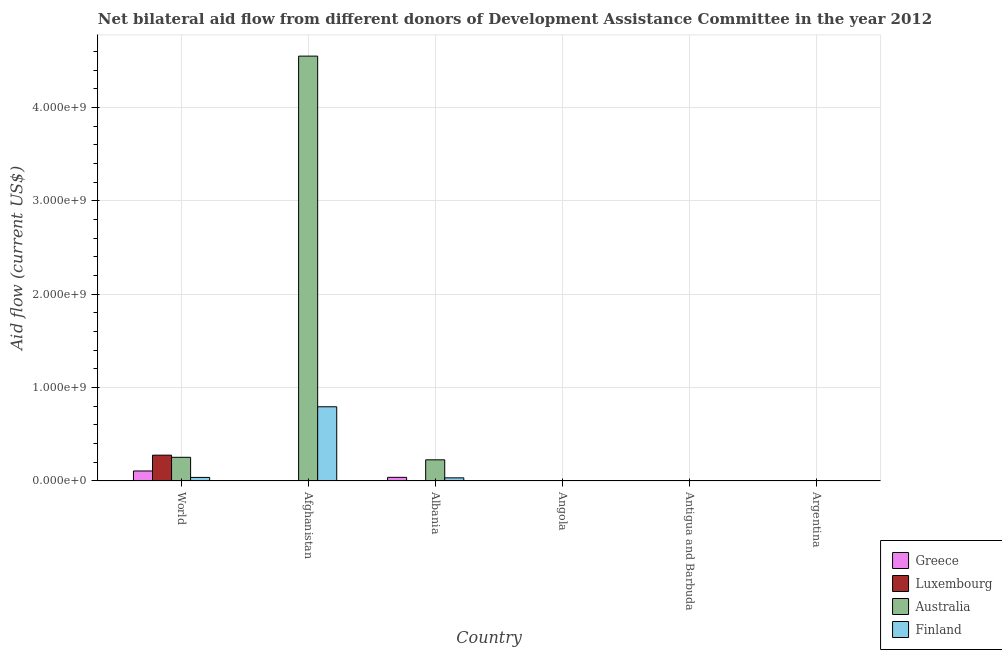How many groups of bars are there?
Give a very brief answer. 6. Are the number of bars per tick equal to the number of legend labels?
Your answer should be very brief. Yes. Are the number of bars on each tick of the X-axis equal?
Your answer should be compact. Yes. How many bars are there on the 5th tick from the right?
Offer a very short reply. 4. What is the label of the 4th group of bars from the left?
Your response must be concise. Angola. What is the amount of aid given by greece in Angola?
Ensure brevity in your answer.  2.00e+04. Across all countries, what is the maximum amount of aid given by greece?
Provide a short and direct response. 1.07e+08. Across all countries, what is the minimum amount of aid given by greece?
Your answer should be very brief. 2.00e+04. In which country was the amount of aid given by luxembourg maximum?
Your response must be concise. World. In which country was the amount of aid given by greece minimum?
Make the answer very short. Angola. What is the total amount of aid given by australia in the graph?
Keep it short and to the point. 5.03e+09. What is the difference between the amount of aid given by greece in Albania and that in World?
Give a very brief answer. -6.80e+07. What is the difference between the amount of aid given by australia in Afghanistan and the amount of aid given by greece in Angola?
Offer a terse response. 4.55e+09. What is the average amount of aid given by luxembourg per country?
Offer a very short reply. 4.67e+07. What is the difference between the amount of aid given by luxembourg and amount of aid given by australia in Angola?
Your response must be concise. 3.00e+04. What is the ratio of the amount of aid given by finland in Albania to that in Angola?
Your answer should be compact. 210.75. Is the difference between the amount of aid given by australia in Argentina and World greater than the difference between the amount of aid given by greece in Argentina and World?
Your response must be concise. No. What is the difference between the highest and the second highest amount of aid given by luxembourg?
Your response must be concise. 2.74e+08. What is the difference between the highest and the lowest amount of aid given by greece?
Your answer should be very brief. 1.07e+08. What does the 2nd bar from the right in Afghanistan represents?
Your answer should be compact. Australia. Is it the case that in every country, the sum of the amount of aid given by greece and amount of aid given by luxembourg is greater than the amount of aid given by australia?
Provide a short and direct response. No. How many countries are there in the graph?
Provide a short and direct response. 6. What is the difference between two consecutive major ticks on the Y-axis?
Keep it short and to the point. 1.00e+09. Does the graph contain grids?
Ensure brevity in your answer.  Yes. Where does the legend appear in the graph?
Give a very brief answer. Bottom right. What is the title of the graph?
Your answer should be very brief. Net bilateral aid flow from different donors of Development Assistance Committee in the year 2012. What is the label or title of the X-axis?
Make the answer very short. Country. What is the Aid flow (current US$) in Greece in World?
Provide a short and direct response. 1.07e+08. What is the Aid flow (current US$) in Luxembourg in World?
Provide a succinct answer. 2.77e+08. What is the Aid flow (current US$) of Australia in World?
Provide a short and direct response. 2.54e+08. What is the Aid flow (current US$) in Finland in World?
Your answer should be very brief. 3.82e+07. What is the Aid flow (current US$) in Greece in Afghanistan?
Offer a terse response. 7.70e+05. What is the Aid flow (current US$) of Luxembourg in Afghanistan?
Your response must be concise. 3.02e+06. What is the Aid flow (current US$) in Australia in Afghanistan?
Offer a very short reply. 4.55e+09. What is the Aid flow (current US$) in Finland in Afghanistan?
Give a very brief answer. 7.95e+08. What is the Aid flow (current US$) in Greece in Albania?
Your answer should be compact. 3.92e+07. What is the Aid flow (current US$) in Australia in Albania?
Your response must be concise. 2.27e+08. What is the Aid flow (current US$) in Finland in Albania?
Provide a succinct answer. 3.37e+07. What is the Aid flow (current US$) of Greece in Antigua and Barbuda?
Your answer should be very brief. 5.00e+04. What is the Aid flow (current US$) of Luxembourg in Antigua and Barbuda?
Make the answer very short. 1.20e+05. What is the Aid flow (current US$) of Australia in Antigua and Barbuda?
Your response must be concise. 1.90e+05. What is the Aid flow (current US$) of Finland in Antigua and Barbuda?
Make the answer very short. 1.86e+06. What is the Aid flow (current US$) of Greece in Argentina?
Offer a terse response. 3.40e+05. What is the Aid flow (current US$) of Luxembourg in Argentina?
Provide a succinct answer. 1.00e+05. What is the Aid flow (current US$) in Finland in Argentina?
Provide a short and direct response. 2.00e+04. Across all countries, what is the maximum Aid flow (current US$) in Greece?
Keep it short and to the point. 1.07e+08. Across all countries, what is the maximum Aid flow (current US$) in Luxembourg?
Give a very brief answer. 2.77e+08. Across all countries, what is the maximum Aid flow (current US$) of Australia?
Ensure brevity in your answer.  4.55e+09. Across all countries, what is the maximum Aid flow (current US$) of Finland?
Keep it short and to the point. 7.95e+08. Across all countries, what is the minimum Aid flow (current US$) in Luxembourg?
Provide a short and direct response. 9.00e+04. Across all countries, what is the minimum Aid flow (current US$) in Australia?
Your response must be concise. 6.00e+04. What is the total Aid flow (current US$) of Greece in the graph?
Your answer should be compact. 1.48e+08. What is the total Aid flow (current US$) of Luxembourg in the graph?
Ensure brevity in your answer.  2.80e+08. What is the total Aid flow (current US$) of Australia in the graph?
Provide a short and direct response. 5.03e+09. What is the total Aid flow (current US$) in Finland in the graph?
Keep it short and to the point. 8.69e+08. What is the difference between the Aid flow (current US$) in Greece in World and that in Afghanistan?
Your response must be concise. 1.07e+08. What is the difference between the Aid flow (current US$) of Luxembourg in World and that in Afghanistan?
Your response must be concise. 2.74e+08. What is the difference between the Aid flow (current US$) in Australia in World and that in Afghanistan?
Keep it short and to the point. -4.30e+09. What is the difference between the Aid flow (current US$) of Finland in World and that in Afghanistan?
Offer a terse response. -7.57e+08. What is the difference between the Aid flow (current US$) in Greece in World and that in Albania?
Offer a terse response. 6.80e+07. What is the difference between the Aid flow (current US$) in Luxembourg in World and that in Albania?
Provide a short and direct response. 2.77e+08. What is the difference between the Aid flow (current US$) of Australia in World and that in Albania?
Your answer should be very brief. 2.71e+07. What is the difference between the Aid flow (current US$) of Finland in World and that in Albania?
Your answer should be compact. 4.53e+06. What is the difference between the Aid flow (current US$) of Greece in World and that in Angola?
Offer a terse response. 1.07e+08. What is the difference between the Aid flow (current US$) in Luxembourg in World and that in Angola?
Your answer should be compact. 2.77e+08. What is the difference between the Aid flow (current US$) of Australia in World and that in Angola?
Offer a very short reply. 2.54e+08. What is the difference between the Aid flow (current US$) in Finland in World and that in Angola?
Provide a short and direct response. 3.81e+07. What is the difference between the Aid flow (current US$) in Greece in World and that in Antigua and Barbuda?
Provide a succinct answer. 1.07e+08. What is the difference between the Aid flow (current US$) of Luxembourg in World and that in Antigua and Barbuda?
Keep it short and to the point. 2.77e+08. What is the difference between the Aid flow (current US$) of Australia in World and that in Antigua and Barbuda?
Give a very brief answer. 2.54e+08. What is the difference between the Aid flow (current US$) of Finland in World and that in Antigua and Barbuda?
Give a very brief answer. 3.64e+07. What is the difference between the Aid flow (current US$) in Greece in World and that in Argentina?
Give a very brief answer. 1.07e+08. What is the difference between the Aid flow (current US$) in Luxembourg in World and that in Argentina?
Offer a terse response. 2.77e+08. What is the difference between the Aid flow (current US$) in Australia in World and that in Argentina?
Your response must be concise. 2.54e+08. What is the difference between the Aid flow (current US$) in Finland in World and that in Argentina?
Make the answer very short. 3.82e+07. What is the difference between the Aid flow (current US$) of Greece in Afghanistan and that in Albania?
Your answer should be compact. -3.85e+07. What is the difference between the Aid flow (current US$) in Luxembourg in Afghanistan and that in Albania?
Give a very brief answer. 2.86e+06. What is the difference between the Aid flow (current US$) of Australia in Afghanistan and that in Albania?
Provide a short and direct response. 4.32e+09. What is the difference between the Aid flow (current US$) in Finland in Afghanistan and that in Albania?
Offer a very short reply. 7.61e+08. What is the difference between the Aid flow (current US$) in Greece in Afghanistan and that in Angola?
Ensure brevity in your answer.  7.50e+05. What is the difference between the Aid flow (current US$) of Luxembourg in Afghanistan and that in Angola?
Ensure brevity in your answer.  2.93e+06. What is the difference between the Aid flow (current US$) in Australia in Afghanistan and that in Angola?
Keep it short and to the point. 4.55e+09. What is the difference between the Aid flow (current US$) of Finland in Afghanistan and that in Angola?
Your answer should be compact. 7.95e+08. What is the difference between the Aid flow (current US$) in Greece in Afghanistan and that in Antigua and Barbuda?
Provide a succinct answer. 7.20e+05. What is the difference between the Aid flow (current US$) of Luxembourg in Afghanistan and that in Antigua and Barbuda?
Your answer should be compact. 2.90e+06. What is the difference between the Aid flow (current US$) in Australia in Afghanistan and that in Antigua and Barbuda?
Your answer should be very brief. 4.55e+09. What is the difference between the Aid flow (current US$) of Finland in Afghanistan and that in Antigua and Barbuda?
Give a very brief answer. 7.93e+08. What is the difference between the Aid flow (current US$) in Greece in Afghanistan and that in Argentina?
Make the answer very short. 4.30e+05. What is the difference between the Aid flow (current US$) in Luxembourg in Afghanistan and that in Argentina?
Offer a terse response. 2.92e+06. What is the difference between the Aid flow (current US$) in Australia in Afghanistan and that in Argentina?
Keep it short and to the point. 4.55e+09. What is the difference between the Aid flow (current US$) in Finland in Afghanistan and that in Argentina?
Keep it short and to the point. 7.95e+08. What is the difference between the Aid flow (current US$) in Greece in Albania and that in Angola?
Your response must be concise. 3.92e+07. What is the difference between the Aid flow (current US$) of Luxembourg in Albania and that in Angola?
Offer a very short reply. 7.00e+04. What is the difference between the Aid flow (current US$) in Australia in Albania and that in Angola?
Offer a terse response. 2.27e+08. What is the difference between the Aid flow (current US$) in Finland in Albania and that in Angola?
Your response must be concise. 3.36e+07. What is the difference between the Aid flow (current US$) in Greece in Albania and that in Antigua and Barbuda?
Give a very brief answer. 3.92e+07. What is the difference between the Aid flow (current US$) in Luxembourg in Albania and that in Antigua and Barbuda?
Offer a terse response. 4.00e+04. What is the difference between the Aid flow (current US$) of Australia in Albania and that in Antigua and Barbuda?
Provide a short and direct response. 2.26e+08. What is the difference between the Aid flow (current US$) in Finland in Albania and that in Antigua and Barbuda?
Keep it short and to the point. 3.19e+07. What is the difference between the Aid flow (current US$) of Greece in Albania and that in Argentina?
Provide a succinct answer. 3.89e+07. What is the difference between the Aid flow (current US$) in Australia in Albania and that in Argentina?
Provide a short and direct response. 2.27e+08. What is the difference between the Aid flow (current US$) in Finland in Albania and that in Argentina?
Ensure brevity in your answer.  3.37e+07. What is the difference between the Aid flow (current US$) in Luxembourg in Angola and that in Antigua and Barbuda?
Provide a short and direct response. -3.00e+04. What is the difference between the Aid flow (current US$) of Finland in Angola and that in Antigua and Barbuda?
Your answer should be very brief. -1.70e+06. What is the difference between the Aid flow (current US$) in Greece in Angola and that in Argentina?
Offer a terse response. -3.20e+05. What is the difference between the Aid flow (current US$) of Luxembourg in Angola and that in Argentina?
Keep it short and to the point. -10000. What is the difference between the Aid flow (current US$) in Australia in Angola and that in Argentina?
Your response must be concise. -8.00e+04. What is the difference between the Aid flow (current US$) in Greece in Antigua and Barbuda and that in Argentina?
Ensure brevity in your answer.  -2.90e+05. What is the difference between the Aid flow (current US$) of Australia in Antigua and Barbuda and that in Argentina?
Your answer should be compact. 5.00e+04. What is the difference between the Aid flow (current US$) in Finland in Antigua and Barbuda and that in Argentina?
Offer a terse response. 1.84e+06. What is the difference between the Aid flow (current US$) in Greece in World and the Aid flow (current US$) in Luxembourg in Afghanistan?
Give a very brief answer. 1.04e+08. What is the difference between the Aid flow (current US$) in Greece in World and the Aid flow (current US$) in Australia in Afghanistan?
Provide a short and direct response. -4.44e+09. What is the difference between the Aid flow (current US$) of Greece in World and the Aid flow (current US$) of Finland in Afghanistan?
Provide a succinct answer. -6.88e+08. What is the difference between the Aid flow (current US$) in Luxembourg in World and the Aid flow (current US$) in Australia in Afghanistan?
Your answer should be compact. -4.27e+09. What is the difference between the Aid flow (current US$) in Luxembourg in World and the Aid flow (current US$) in Finland in Afghanistan?
Your answer should be compact. -5.18e+08. What is the difference between the Aid flow (current US$) of Australia in World and the Aid flow (current US$) of Finland in Afghanistan?
Make the answer very short. -5.41e+08. What is the difference between the Aid flow (current US$) in Greece in World and the Aid flow (current US$) in Luxembourg in Albania?
Offer a very short reply. 1.07e+08. What is the difference between the Aid flow (current US$) in Greece in World and the Aid flow (current US$) in Australia in Albania?
Ensure brevity in your answer.  -1.19e+08. What is the difference between the Aid flow (current US$) of Greece in World and the Aid flow (current US$) of Finland in Albania?
Your answer should be very brief. 7.36e+07. What is the difference between the Aid flow (current US$) in Luxembourg in World and the Aid flow (current US$) in Australia in Albania?
Give a very brief answer. 5.00e+07. What is the difference between the Aid flow (current US$) of Luxembourg in World and the Aid flow (current US$) of Finland in Albania?
Ensure brevity in your answer.  2.43e+08. What is the difference between the Aid flow (current US$) of Australia in World and the Aid flow (current US$) of Finland in Albania?
Keep it short and to the point. 2.20e+08. What is the difference between the Aid flow (current US$) of Greece in World and the Aid flow (current US$) of Luxembourg in Angola?
Provide a succinct answer. 1.07e+08. What is the difference between the Aid flow (current US$) in Greece in World and the Aid flow (current US$) in Australia in Angola?
Make the answer very short. 1.07e+08. What is the difference between the Aid flow (current US$) of Greece in World and the Aid flow (current US$) of Finland in Angola?
Ensure brevity in your answer.  1.07e+08. What is the difference between the Aid flow (current US$) in Luxembourg in World and the Aid flow (current US$) in Australia in Angola?
Ensure brevity in your answer.  2.77e+08. What is the difference between the Aid flow (current US$) of Luxembourg in World and the Aid flow (current US$) of Finland in Angola?
Keep it short and to the point. 2.77e+08. What is the difference between the Aid flow (current US$) in Australia in World and the Aid flow (current US$) in Finland in Angola?
Make the answer very short. 2.54e+08. What is the difference between the Aid flow (current US$) in Greece in World and the Aid flow (current US$) in Luxembourg in Antigua and Barbuda?
Provide a succinct answer. 1.07e+08. What is the difference between the Aid flow (current US$) of Greece in World and the Aid flow (current US$) of Australia in Antigua and Barbuda?
Make the answer very short. 1.07e+08. What is the difference between the Aid flow (current US$) of Greece in World and the Aid flow (current US$) of Finland in Antigua and Barbuda?
Ensure brevity in your answer.  1.05e+08. What is the difference between the Aid flow (current US$) of Luxembourg in World and the Aid flow (current US$) of Australia in Antigua and Barbuda?
Offer a very short reply. 2.76e+08. What is the difference between the Aid flow (current US$) in Luxembourg in World and the Aid flow (current US$) in Finland in Antigua and Barbuda?
Offer a terse response. 2.75e+08. What is the difference between the Aid flow (current US$) of Australia in World and the Aid flow (current US$) of Finland in Antigua and Barbuda?
Make the answer very short. 2.52e+08. What is the difference between the Aid flow (current US$) of Greece in World and the Aid flow (current US$) of Luxembourg in Argentina?
Make the answer very short. 1.07e+08. What is the difference between the Aid flow (current US$) in Greece in World and the Aid flow (current US$) in Australia in Argentina?
Offer a very short reply. 1.07e+08. What is the difference between the Aid flow (current US$) in Greece in World and the Aid flow (current US$) in Finland in Argentina?
Ensure brevity in your answer.  1.07e+08. What is the difference between the Aid flow (current US$) of Luxembourg in World and the Aid flow (current US$) of Australia in Argentina?
Provide a short and direct response. 2.77e+08. What is the difference between the Aid flow (current US$) in Luxembourg in World and the Aid flow (current US$) in Finland in Argentina?
Your answer should be very brief. 2.77e+08. What is the difference between the Aid flow (current US$) in Australia in World and the Aid flow (current US$) in Finland in Argentina?
Your response must be concise. 2.54e+08. What is the difference between the Aid flow (current US$) in Greece in Afghanistan and the Aid flow (current US$) in Australia in Albania?
Provide a short and direct response. -2.26e+08. What is the difference between the Aid flow (current US$) in Greece in Afghanistan and the Aid flow (current US$) in Finland in Albania?
Offer a very short reply. -3.30e+07. What is the difference between the Aid flow (current US$) of Luxembourg in Afghanistan and the Aid flow (current US$) of Australia in Albania?
Your answer should be very brief. -2.24e+08. What is the difference between the Aid flow (current US$) of Luxembourg in Afghanistan and the Aid flow (current US$) of Finland in Albania?
Your answer should be very brief. -3.07e+07. What is the difference between the Aid flow (current US$) in Australia in Afghanistan and the Aid flow (current US$) in Finland in Albania?
Your response must be concise. 4.52e+09. What is the difference between the Aid flow (current US$) of Greece in Afghanistan and the Aid flow (current US$) of Luxembourg in Angola?
Provide a succinct answer. 6.80e+05. What is the difference between the Aid flow (current US$) in Greece in Afghanistan and the Aid flow (current US$) in Australia in Angola?
Keep it short and to the point. 7.10e+05. What is the difference between the Aid flow (current US$) of Greece in Afghanistan and the Aid flow (current US$) of Finland in Angola?
Your answer should be compact. 6.10e+05. What is the difference between the Aid flow (current US$) of Luxembourg in Afghanistan and the Aid flow (current US$) of Australia in Angola?
Offer a very short reply. 2.96e+06. What is the difference between the Aid flow (current US$) in Luxembourg in Afghanistan and the Aid flow (current US$) in Finland in Angola?
Offer a terse response. 2.86e+06. What is the difference between the Aid flow (current US$) of Australia in Afghanistan and the Aid flow (current US$) of Finland in Angola?
Offer a very short reply. 4.55e+09. What is the difference between the Aid flow (current US$) in Greece in Afghanistan and the Aid flow (current US$) in Luxembourg in Antigua and Barbuda?
Make the answer very short. 6.50e+05. What is the difference between the Aid flow (current US$) in Greece in Afghanistan and the Aid flow (current US$) in Australia in Antigua and Barbuda?
Provide a short and direct response. 5.80e+05. What is the difference between the Aid flow (current US$) of Greece in Afghanistan and the Aid flow (current US$) of Finland in Antigua and Barbuda?
Offer a terse response. -1.09e+06. What is the difference between the Aid flow (current US$) in Luxembourg in Afghanistan and the Aid flow (current US$) in Australia in Antigua and Barbuda?
Make the answer very short. 2.83e+06. What is the difference between the Aid flow (current US$) of Luxembourg in Afghanistan and the Aid flow (current US$) of Finland in Antigua and Barbuda?
Offer a terse response. 1.16e+06. What is the difference between the Aid flow (current US$) of Australia in Afghanistan and the Aid flow (current US$) of Finland in Antigua and Barbuda?
Your answer should be very brief. 4.55e+09. What is the difference between the Aid flow (current US$) in Greece in Afghanistan and the Aid flow (current US$) in Luxembourg in Argentina?
Offer a very short reply. 6.70e+05. What is the difference between the Aid flow (current US$) in Greece in Afghanistan and the Aid flow (current US$) in Australia in Argentina?
Ensure brevity in your answer.  6.30e+05. What is the difference between the Aid flow (current US$) in Greece in Afghanistan and the Aid flow (current US$) in Finland in Argentina?
Make the answer very short. 7.50e+05. What is the difference between the Aid flow (current US$) of Luxembourg in Afghanistan and the Aid flow (current US$) of Australia in Argentina?
Offer a very short reply. 2.88e+06. What is the difference between the Aid flow (current US$) in Australia in Afghanistan and the Aid flow (current US$) in Finland in Argentina?
Your response must be concise. 4.55e+09. What is the difference between the Aid flow (current US$) in Greece in Albania and the Aid flow (current US$) in Luxembourg in Angola?
Keep it short and to the point. 3.92e+07. What is the difference between the Aid flow (current US$) in Greece in Albania and the Aid flow (current US$) in Australia in Angola?
Keep it short and to the point. 3.92e+07. What is the difference between the Aid flow (current US$) in Greece in Albania and the Aid flow (current US$) in Finland in Angola?
Offer a terse response. 3.91e+07. What is the difference between the Aid flow (current US$) in Luxembourg in Albania and the Aid flow (current US$) in Australia in Angola?
Make the answer very short. 1.00e+05. What is the difference between the Aid flow (current US$) of Australia in Albania and the Aid flow (current US$) of Finland in Angola?
Make the answer very short. 2.27e+08. What is the difference between the Aid flow (current US$) in Greece in Albania and the Aid flow (current US$) in Luxembourg in Antigua and Barbuda?
Offer a terse response. 3.91e+07. What is the difference between the Aid flow (current US$) in Greece in Albania and the Aid flow (current US$) in Australia in Antigua and Barbuda?
Your response must be concise. 3.90e+07. What is the difference between the Aid flow (current US$) of Greece in Albania and the Aid flow (current US$) of Finland in Antigua and Barbuda?
Provide a succinct answer. 3.74e+07. What is the difference between the Aid flow (current US$) of Luxembourg in Albania and the Aid flow (current US$) of Finland in Antigua and Barbuda?
Offer a very short reply. -1.70e+06. What is the difference between the Aid flow (current US$) in Australia in Albania and the Aid flow (current US$) in Finland in Antigua and Barbuda?
Keep it short and to the point. 2.25e+08. What is the difference between the Aid flow (current US$) in Greece in Albania and the Aid flow (current US$) in Luxembourg in Argentina?
Make the answer very short. 3.91e+07. What is the difference between the Aid flow (current US$) in Greece in Albania and the Aid flow (current US$) in Australia in Argentina?
Offer a very short reply. 3.91e+07. What is the difference between the Aid flow (current US$) of Greece in Albania and the Aid flow (current US$) of Finland in Argentina?
Your response must be concise. 3.92e+07. What is the difference between the Aid flow (current US$) of Australia in Albania and the Aid flow (current US$) of Finland in Argentina?
Keep it short and to the point. 2.27e+08. What is the difference between the Aid flow (current US$) in Greece in Angola and the Aid flow (current US$) in Luxembourg in Antigua and Barbuda?
Your answer should be very brief. -1.00e+05. What is the difference between the Aid flow (current US$) in Greece in Angola and the Aid flow (current US$) in Finland in Antigua and Barbuda?
Ensure brevity in your answer.  -1.84e+06. What is the difference between the Aid flow (current US$) of Luxembourg in Angola and the Aid flow (current US$) of Finland in Antigua and Barbuda?
Your response must be concise. -1.77e+06. What is the difference between the Aid flow (current US$) of Australia in Angola and the Aid flow (current US$) of Finland in Antigua and Barbuda?
Offer a terse response. -1.80e+06. What is the difference between the Aid flow (current US$) of Greece in Angola and the Aid flow (current US$) of Luxembourg in Argentina?
Your answer should be very brief. -8.00e+04. What is the difference between the Aid flow (current US$) of Greece in Angola and the Aid flow (current US$) of Finland in Argentina?
Make the answer very short. 0. What is the difference between the Aid flow (current US$) of Luxembourg in Angola and the Aid flow (current US$) of Australia in Argentina?
Your answer should be compact. -5.00e+04. What is the difference between the Aid flow (current US$) in Greece in Antigua and Barbuda and the Aid flow (current US$) in Australia in Argentina?
Offer a very short reply. -9.00e+04. What is the difference between the Aid flow (current US$) of Greece in Antigua and Barbuda and the Aid flow (current US$) of Finland in Argentina?
Your answer should be very brief. 3.00e+04. What is the difference between the Aid flow (current US$) in Luxembourg in Antigua and Barbuda and the Aid flow (current US$) in Australia in Argentina?
Your answer should be very brief. -2.00e+04. What is the difference between the Aid flow (current US$) of Luxembourg in Antigua and Barbuda and the Aid flow (current US$) of Finland in Argentina?
Give a very brief answer. 1.00e+05. What is the average Aid flow (current US$) in Greece per country?
Give a very brief answer. 2.46e+07. What is the average Aid flow (current US$) of Luxembourg per country?
Your answer should be compact. 4.67e+07. What is the average Aid flow (current US$) of Australia per country?
Make the answer very short. 8.39e+08. What is the average Aid flow (current US$) of Finland per country?
Give a very brief answer. 1.45e+08. What is the difference between the Aid flow (current US$) of Greece and Aid flow (current US$) of Luxembourg in World?
Offer a terse response. -1.69e+08. What is the difference between the Aid flow (current US$) in Greece and Aid flow (current US$) in Australia in World?
Offer a very short reply. -1.46e+08. What is the difference between the Aid flow (current US$) in Greece and Aid flow (current US$) in Finland in World?
Your answer should be compact. 6.90e+07. What is the difference between the Aid flow (current US$) in Luxembourg and Aid flow (current US$) in Australia in World?
Your answer should be compact. 2.29e+07. What is the difference between the Aid flow (current US$) in Luxembourg and Aid flow (current US$) in Finland in World?
Provide a short and direct response. 2.38e+08. What is the difference between the Aid flow (current US$) in Australia and Aid flow (current US$) in Finland in World?
Offer a terse response. 2.16e+08. What is the difference between the Aid flow (current US$) of Greece and Aid flow (current US$) of Luxembourg in Afghanistan?
Your answer should be very brief. -2.25e+06. What is the difference between the Aid flow (current US$) in Greece and Aid flow (current US$) in Australia in Afghanistan?
Give a very brief answer. -4.55e+09. What is the difference between the Aid flow (current US$) in Greece and Aid flow (current US$) in Finland in Afghanistan?
Your answer should be very brief. -7.94e+08. What is the difference between the Aid flow (current US$) of Luxembourg and Aid flow (current US$) of Australia in Afghanistan?
Your response must be concise. -4.55e+09. What is the difference between the Aid flow (current US$) in Luxembourg and Aid flow (current US$) in Finland in Afghanistan?
Give a very brief answer. -7.92e+08. What is the difference between the Aid flow (current US$) of Australia and Aid flow (current US$) of Finland in Afghanistan?
Offer a very short reply. 3.76e+09. What is the difference between the Aid flow (current US$) of Greece and Aid flow (current US$) of Luxembourg in Albania?
Make the answer very short. 3.91e+07. What is the difference between the Aid flow (current US$) of Greece and Aid flow (current US$) of Australia in Albania?
Give a very brief answer. -1.87e+08. What is the difference between the Aid flow (current US$) of Greece and Aid flow (current US$) of Finland in Albania?
Provide a succinct answer. 5.52e+06. What is the difference between the Aid flow (current US$) of Luxembourg and Aid flow (current US$) of Australia in Albania?
Offer a very short reply. -2.27e+08. What is the difference between the Aid flow (current US$) in Luxembourg and Aid flow (current US$) in Finland in Albania?
Keep it short and to the point. -3.36e+07. What is the difference between the Aid flow (current US$) of Australia and Aid flow (current US$) of Finland in Albania?
Make the answer very short. 1.93e+08. What is the difference between the Aid flow (current US$) of Greece and Aid flow (current US$) of Luxembourg in Angola?
Give a very brief answer. -7.00e+04. What is the difference between the Aid flow (current US$) in Greece and Aid flow (current US$) in Australia in Angola?
Keep it short and to the point. -4.00e+04. What is the difference between the Aid flow (current US$) of Luxembourg and Aid flow (current US$) of Finland in Angola?
Keep it short and to the point. -7.00e+04. What is the difference between the Aid flow (current US$) of Australia and Aid flow (current US$) of Finland in Angola?
Give a very brief answer. -1.00e+05. What is the difference between the Aid flow (current US$) in Greece and Aid flow (current US$) in Australia in Antigua and Barbuda?
Your answer should be compact. -1.40e+05. What is the difference between the Aid flow (current US$) in Greece and Aid flow (current US$) in Finland in Antigua and Barbuda?
Make the answer very short. -1.81e+06. What is the difference between the Aid flow (current US$) of Luxembourg and Aid flow (current US$) of Finland in Antigua and Barbuda?
Provide a short and direct response. -1.74e+06. What is the difference between the Aid flow (current US$) in Australia and Aid flow (current US$) in Finland in Antigua and Barbuda?
Offer a terse response. -1.67e+06. What is the difference between the Aid flow (current US$) of Greece and Aid flow (current US$) of Luxembourg in Argentina?
Provide a succinct answer. 2.40e+05. What is the difference between the Aid flow (current US$) of Luxembourg and Aid flow (current US$) of Finland in Argentina?
Keep it short and to the point. 8.00e+04. What is the difference between the Aid flow (current US$) in Australia and Aid flow (current US$) in Finland in Argentina?
Your response must be concise. 1.20e+05. What is the ratio of the Aid flow (current US$) of Greece in World to that in Afghanistan?
Your answer should be very brief. 139.34. What is the ratio of the Aid flow (current US$) in Luxembourg in World to that in Afghanistan?
Your response must be concise. 91.61. What is the ratio of the Aid flow (current US$) of Australia in World to that in Afghanistan?
Your answer should be very brief. 0.06. What is the ratio of the Aid flow (current US$) of Finland in World to that in Afghanistan?
Make the answer very short. 0.05. What is the ratio of the Aid flow (current US$) of Greece in World to that in Albania?
Offer a very short reply. 2.73. What is the ratio of the Aid flow (current US$) in Luxembourg in World to that in Albania?
Make the answer very short. 1729.19. What is the ratio of the Aid flow (current US$) in Australia in World to that in Albania?
Offer a very short reply. 1.12. What is the ratio of the Aid flow (current US$) of Finland in World to that in Albania?
Provide a succinct answer. 1.13. What is the ratio of the Aid flow (current US$) of Greece in World to that in Angola?
Ensure brevity in your answer.  5364.5. What is the ratio of the Aid flow (current US$) in Luxembourg in World to that in Angola?
Your response must be concise. 3074.11. What is the ratio of the Aid flow (current US$) in Australia in World to that in Angola?
Offer a very short reply. 4229.5. What is the ratio of the Aid flow (current US$) of Finland in World to that in Angola?
Give a very brief answer. 239.06. What is the ratio of the Aid flow (current US$) of Greece in World to that in Antigua and Barbuda?
Make the answer very short. 2145.8. What is the ratio of the Aid flow (current US$) of Luxembourg in World to that in Antigua and Barbuda?
Your answer should be compact. 2305.58. What is the ratio of the Aid flow (current US$) in Australia in World to that in Antigua and Barbuda?
Give a very brief answer. 1335.63. What is the ratio of the Aid flow (current US$) in Finland in World to that in Antigua and Barbuda?
Your response must be concise. 20.56. What is the ratio of the Aid flow (current US$) in Greece in World to that in Argentina?
Provide a succinct answer. 315.56. What is the ratio of the Aid flow (current US$) of Luxembourg in World to that in Argentina?
Make the answer very short. 2766.7. What is the ratio of the Aid flow (current US$) in Australia in World to that in Argentina?
Make the answer very short. 1812.64. What is the ratio of the Aid flow (current US$) in Finland in World to that in Argentina?
Ensure brevity in your answer.  1912.5. What is the ratio of the Aid flow (current US$) of Greece in Afghanistan to that in Albania?
Your answer should be compact. 0.02. What is the ratio of the Aid flow (current US$) of Luxembourg in Afghanistan to that in Albania?
Your answer should be compact. 18.88. What is the ratio of the Aid flow (current US$) of Australia in Afghanistan to that in Albania?
Provide a short and direct response. 20.07. What is the ratio of the Aid flow (current US$) of Finland in Afghanistan to that in Albania?
Your answer should be compact. 23.58. What is the ratio of the Aid flow (current US$) of Greece in Afghanistan to that in Angola?
Keep it short and to the point. 38.5. What is the ratio of the Aid flow (current US$) of Luxembourg in Afghanistan to that in Angola?
Provide a short and direct response. 33.56. What is the ratio of the Aid flow (current US$) of Australia in Afghanistan to that in Angola?
Offer a terse response. 7.58e+04. What is the ratio of the Aid flow (current US$) in Finland in Afghanistan to that in Angola?
Your answer should be very brief. 4968.56. What is the ratio of the Aid flow (current US$) of Greece in Afghanistan to that in Antigua and Barbuda?
Offer a very short reply. 15.4. What is the ratio of the Aid flow (current US$) of Luxembourg in Afghanistan to that in Antigua and Barbuda?
Offer a very short reply. 25.17. What is the ratio of the Aid flow (current US$) in Australia in Afghanistan to that in Antigua and Barbuda?
Your answer should be very brief. 2.39e+04. What is the ratio of the Aid flow (current US$) in Finland in Afghanistan to that in Antigua and Barbuda?
Ensure brevity in your answer.  427.4. What is the ratio of the Aid flow (current US$) in Greece in Afghanistan to that in Argentina?
Your response must be concise. 2.26. What is the ratio of the Aid flow (current US$) of Luxembourg in Afghanistan to that in Argentina?
Provide a short and direct response. 30.2. What is the ratio of the Aid flow (current US$) of Australia in Afghanistan to that in Argentina?
Keep it short and to the point. 3.25e+04. What is the ratio of the Aid flow (current US$) of Finland in Afghanistan to that in Argentina?
Keep it short and to the point. 3.97e+04. What is the ratio of the Aid flow (current US$) of Greece in Albania to that in Angola?
Give a very brief answer. 1962. What is the ratio of the Aid flow (current US$) of Luxembourg in Albania to that in Angola?
Give a very brief answer. 1.78. What is the ratio of the Aid flow (current US$) of Australia in Albania to that in Angola?
Offer a very short reply. 3778. What is the ratio of the Aid flow (current US$) in Finland in Albania to that in Angola?
Provide a short and direct response. 210.75. What is the ratio of the Aid flow (current US$) of Greece in Albania to that in Antigua and Barbuda?
Offer a very short reply. 784.8. What is the ratio of the Aid flow (current US$) in Luxembourg in Albania to that in Antigua and Barbuda?
Keep it short and to the point. 1.33. What is the ratio of the Aid flow (current US$) in Australia in Albania to that in Antigua and Barbuda?
Provide a succinct answer. 1193.05. What is the ratio of the Aid flow (current US$) in Finland in Albania to that in Antigua and Barbuda?
Your answer should be very brief. 18.13. What is the ratio of the Aid flow (current US$) of Greece in Albania to that in Argentina?
Provide a short and direct response. 115.41. What is the ratio of the Aid flow (current US$) in Australia in Albania to that in Argentina?
Keep it short and to the point. 1619.14. What is the ratio of the Aid flow (current US$) of Finland in Albania to that in Argentina?
Provide a succinct answer. 1686. What is the ratio of the Aid flow (current US$) in Greece in Angola to that in Antigua and Barbuda?
Your answer should be very brief. 0.4. What is the ratio of the Aid flow (current US$) of Australia in Angola to that in Antigua and Barbuda?
Ensure brevity in your answer.  0.32. What is the ratio of the Aid flow (current US$) in Finland in Angola to that in Antigua and Barbuda?
Make the answer very short. 0.09. What is the ratio of the Aid flow (current US$) in Greece in Angola to that in Argentina?
Your answer should be very brief. 0.06. What is the ratio of the Aid flow (current US$) in Australia in Angola to that in Argentina?
Provide a succinct answer. 0.43. What is the ratio of the Aid flow (current US$) in Greece in Antigua and Barbuda to that in Argentina?
Your response must be concise. 0.15. What is the ratio of the Aid flow (current US$) of Luxembourg in Antigua and Barbuda to that in Argentina?
Ensure brevity in your answer.  1.2. What is the ratio of the Aid flow (current US$) in Australia in Antigua and Barbuda to that in Argentina?
Your response must be concise. 1.36. What is the ratio of the Aid flow (current US$) of Finland in Antigua and Barbuda to that in Argentina?
Offer a very short reply. 93. What is the difference between the highest and the second highest Aid flow (current US$) in Greece?
Keep it short and to the point. 6.80e+07. What is the difference between the highest and the second highest Aid flow (current US$) of Luxembourg?
Provide a short and direct response. 2.74e+08. What is the difference between the highest and the second highest Aid flow (current US$) of Australia?
Make the answer very short. 4.30e+09. What is the difference between the highest and the second highest Aid flow (current US$) of Finland?
Provide a short and direct response. 7.57e+08. What is the difference between the highest and the lowest Aid flow (current US$) in Greece?
Give a very brief answer. 1.07e+08. What is the difference between the highest and the lowest Aid flow (current US$) in Luxembourg?
Your response must be concise. 2.77e+08. What is the difference between the highest and the lowest Aid flow (current US$) of Australia?
Provide a succinct answer. 4.55e+09. What is the difference between the highest and the lowest Aid flow (current US$) in Finland?
Give a very brief answer. 7.95e+08. 